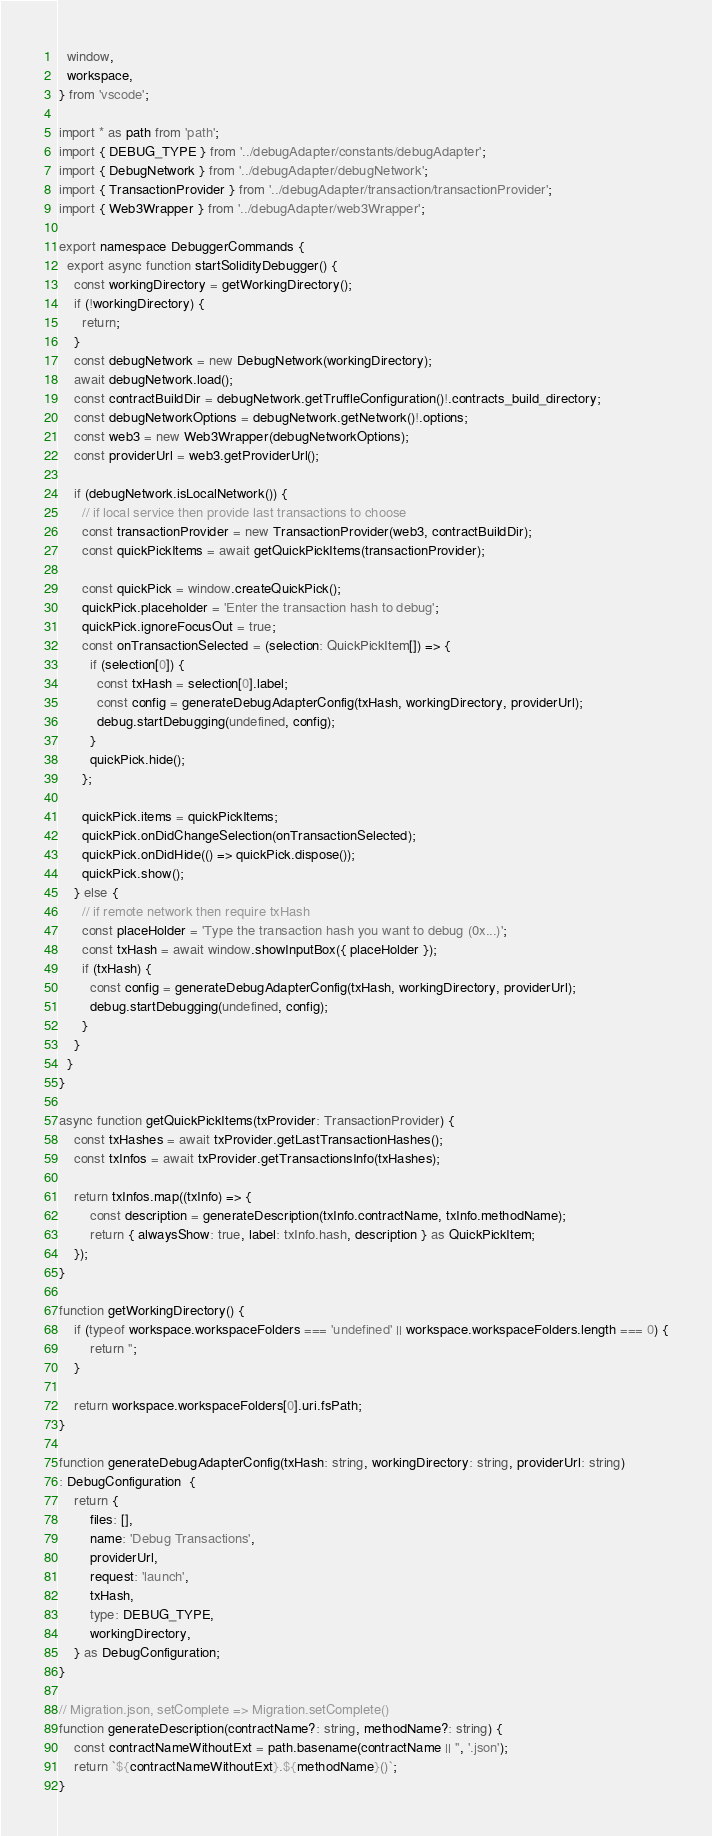<code> <loc_0><loc_0><loc_500><loc_500><_TypeScript_>  window,
  workspace,
} from 'vscode';

import * as path from 'path';
import { DEBUG_TYPE } from '../debugAdapter/constants/debugAdapter';
import { DebugNetwork } from '../debugAdapter/debugNetwork';
import { TransactionProvider } from '../debugAdapter/transaction/transactionProvider';
import { Web3Wrapper } from '../debugAdapter/web3Wrapper';

export namespace DebuggerCommands {
  export async function startSolidityDebugger() {
    const workingDirectory = getWorkingDirectory();
    if (!workingDirectory) {
      return;
    }
    const debugNetwork = new DebugNetwork(workingDirectory);
    await debugNetwork.load();
    const contractBuildDir = debugNetwork.getTruffleConfiguration()!.contracts_build_directory;
    const debugNetworkOptions = debugNetwork.getNetwork()!.options;
    const web3 = new Web3Wrapper(debugNetworkOptions);
    const providerUrl = web3.getProviderUrl();

    if (debugNetwork.isLocalNetwork()) {
      // if local service then provide last transactions to choose
      const transactionProvider = new TransactionProvider(web3, contractBuildDir);
      const quickPickItems = await getQuickPickItems(transactionProvider);

      const quickPick = window.createQuickPick();
      quickPick.placeholder = 'Enter the transaction hash to debug';
      quickPick.ignoreFocusOut = true;
      const onTransactionSelected = (selection: QuickPickItem[]) => {
        if (selection[0]) {
          const txHash = selection[0].label;
          const config = generateDebugAdapterConfig(txHash, workingDirectory, providerUrl);
          debug.startDebugging(undefined, config);
        }
        quickPick.hide();
      };

      quickPick.items = quickPickItems;
      quickPick.onDidChangeSelection(onTransactionSelected);
      quickPick.onDidHide(() => quickPick.dispose());
      quickPick.show();
    } else {
      // if remote network then require txHash
      const placeHolder = 'Type the transaction hash you want to debug (0x...)';
      const txHash = await window.showInputBox({ placeHolder });
      if (txHash) {
        const config = generateDebugAdapterConfig(txHash, workingDirectory, providerUrl);
        debug.startDebugging(undefined, config);
      }
    }
  }
}

async function getQuickPickItems(txProvider: TransactionProvider) {
    const txHashes = await txProvider.getLastTransactionHashes();
    const txInfos = await txProvider.getTransactionsInfo(txHashes);

    return txInfos.map((txInfo) => {
        const description = generateDescription(txInfo.contractName, txInfo.methodName);
        return { alwaysShow: true, label: txInfo.hash, description } as QuickPickItem;
    });
}

function getWorkingDirectory() {
    if (typeof workspace.workspaceFolders === 'undefined' || workspace.workspaceFolders.length === 0) {
        return '';
    }

    return workspace.workspaceFolders[0].uri.fsPath;
}

function generateDebugAdapterConfig(txHash: string, workingDirectory: string, providerUrl: string)
: DebugConfiguration  {
    return {
        files: [],
        name: 'Debug Transactions',
        providerUrl,
        request: 'launch',
        txHash,
        type: DEBUG_TYPE,
        workingDirectory,
    } as DebugConfiguration;
}

// Migration.json, setComplete => Migration.setComplete()
function generateDescription(contractName?: string, methodName?: string) {
    const contractNameWithoutExt = path.basename(contractName || '', '.json');
    return `${contractNameWithoutExt}.${methodName}()`;
}
</code> 